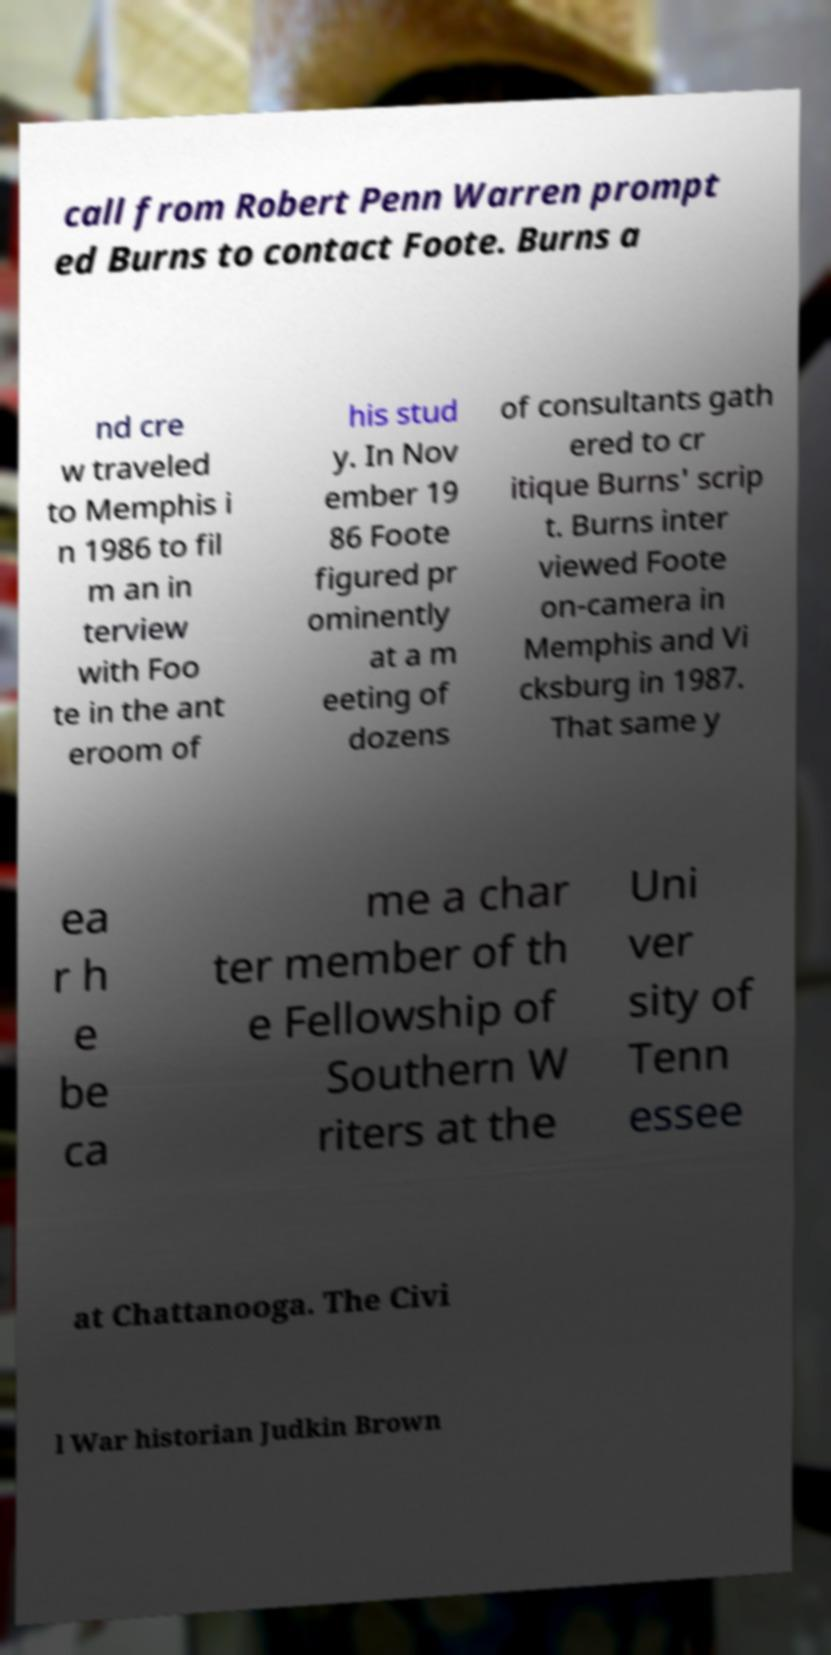I need the written content from this picture converted into text. Can you do that? call from Robert Penn Warren prompt ed Burns to contact Foote. Burns a nd cre w traveled to Memphis i n 1986 to fil m an in terview with Foo te in the ant eroom of his stud y. In Nov ember 19 86 Foote figured pr ominently at a m eeting of dozens of consultants gath ered to cr itique Burns' scrip t. Burns inter viewed Foote on-camera in Memphis and Vi cksburg in 1987. That same y ea r h e be ca me a char ter member of th e Fellowship of Southern W riters at the Uni ver sity of Tenn essee at Chattanooga. The Civi l War historian Judkin Brown 